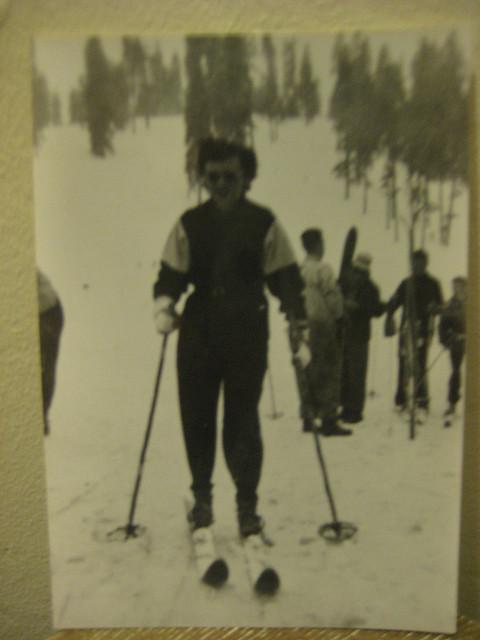How many ski can you see?
Give a very brief answer. 1. How many people are there?
Give a very brief answer. 6. 